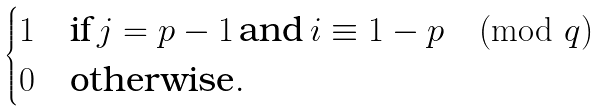<formula> <loc_0><loc_0><loc_500><loc_500>\begin{cases} 1 & \text {if} \, j = p - 1 \, \text {and} \, i \equiv 1 - p \pmod { q } \\ 0 & \text {otherwise} . \end{cases}</formula> 